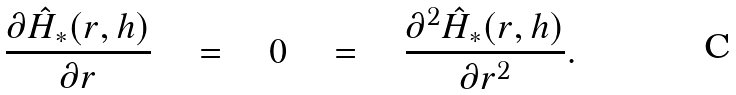<formula> <loc_0><loc_0><loc_500><loc_500>\frac { \partial \hat { H } _ { * } ( r , h ) } { \partial r } \quad = \quad 0 \quad = \quad \frac { \partial ^ { 2 } \hat { H } _ { * } ( r , h ) } { \partial r ^ { 2 } } .</formula> 